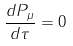<formula> <loc_0><loc_0><loc_500><loc_500>\frac { d P _ { \mu } } { d \tau } = 0</formula> 